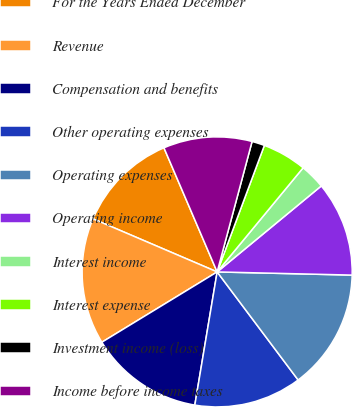Convert chart. <chart><loc_0><loc_0><loc_500><loc_500><pie_chart><fcel>For the Years Ended December<fcel>Revenue<fcel>Compensation and benefits<fcel>Other operating expenses<fcel>Operating expenses<fcel>Operating income<fcel>Interest income<fcel>Interest expense<fcel>Investment income (loss)<fcel>Income before income taxes<nl><fcel>12.12%<fcel>15.15%<fcel>13.64%<fcel>12.88%<fcel>14.39%<fcel>11.36%<fcel>3.03%<fcel>5.3%<fcel>1.52%<fcel>10.61%<nl></chart> 